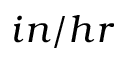Convert formula to latex. <formula><loc_0><loc_0><loc_500><loc_500>i n / h r</formula> 